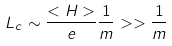Convert formula to latex. <formula><loc_0><loc_0><loc_500><loc_500>L _ { c } \sim \frac { < H > } { e } \frac { 1 } { m } > > \frac { 1 } { m }</formula> 